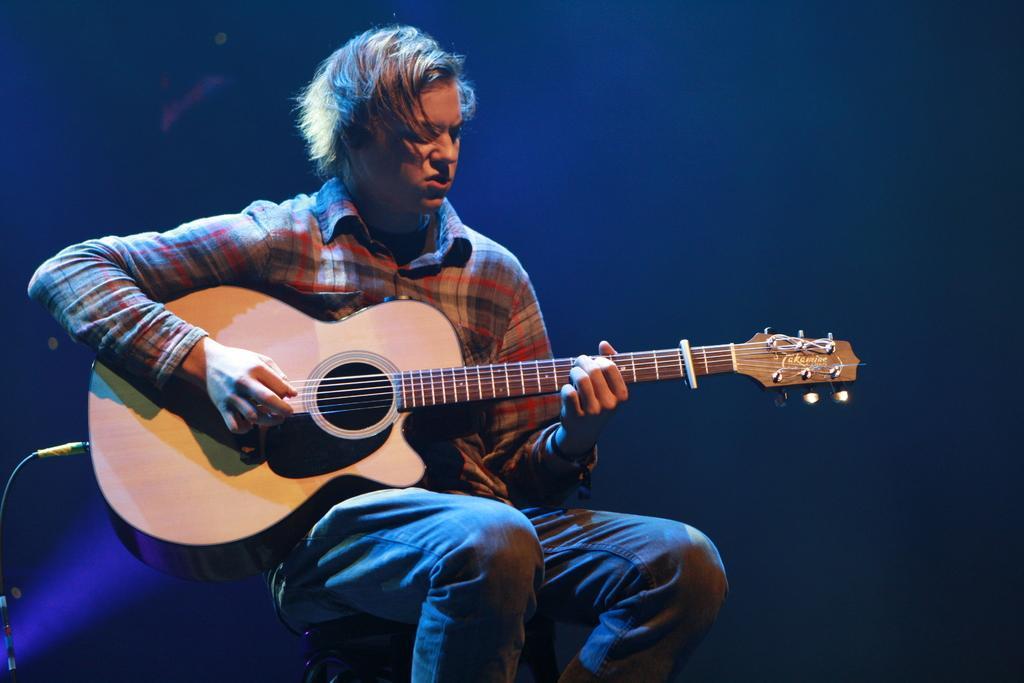Could you give a brief overview of what you see in this image? A person wearing a check shirt holding a guitar and playing. In the background it is blue. He is sitting on something. 